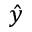Convert formula to latex. <formula><loc_0><loc_0><loc_500><loc_500>\hat { y }</formula> 